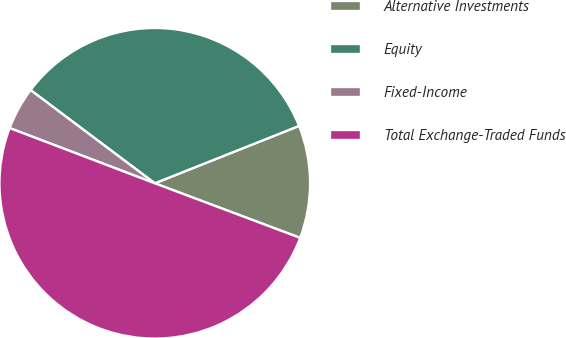Convert chart to OTSL. <chart><loc_0><loc_0><loc_500><loc_500><pie_chart><fcel>Alternative Investments<fcel>Equity<fcel>Fixed-Income<fcel>Total Exchange-Traded Funds<nl><fcel>11.74%<fcel>33.73%<fcel>4.46%<fcel>50.07%<nl></chart> 